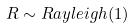Convert formula to latex. <formula><loc_0><loc_0><loc_500><loc_500>R \sim R a y l e i g h ( 1 )</formula> 